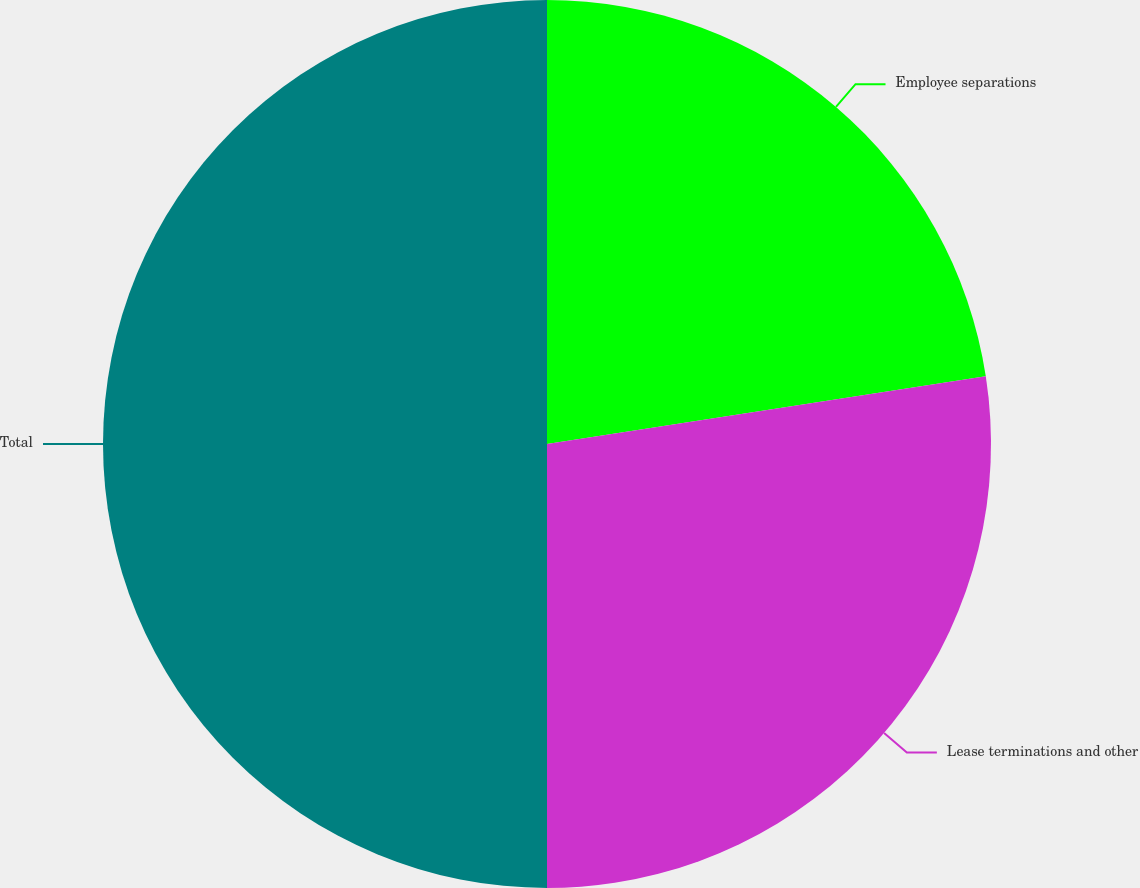<chart> <loc_0><loc_0><loc_500><loc_500><pie_chart><fcel>Employee separations<fcel>Lease terminations and other<fcel>Total<nl><fcel>22.56%<fcel>27.44%<fcel>50.0%<nl></chart> 